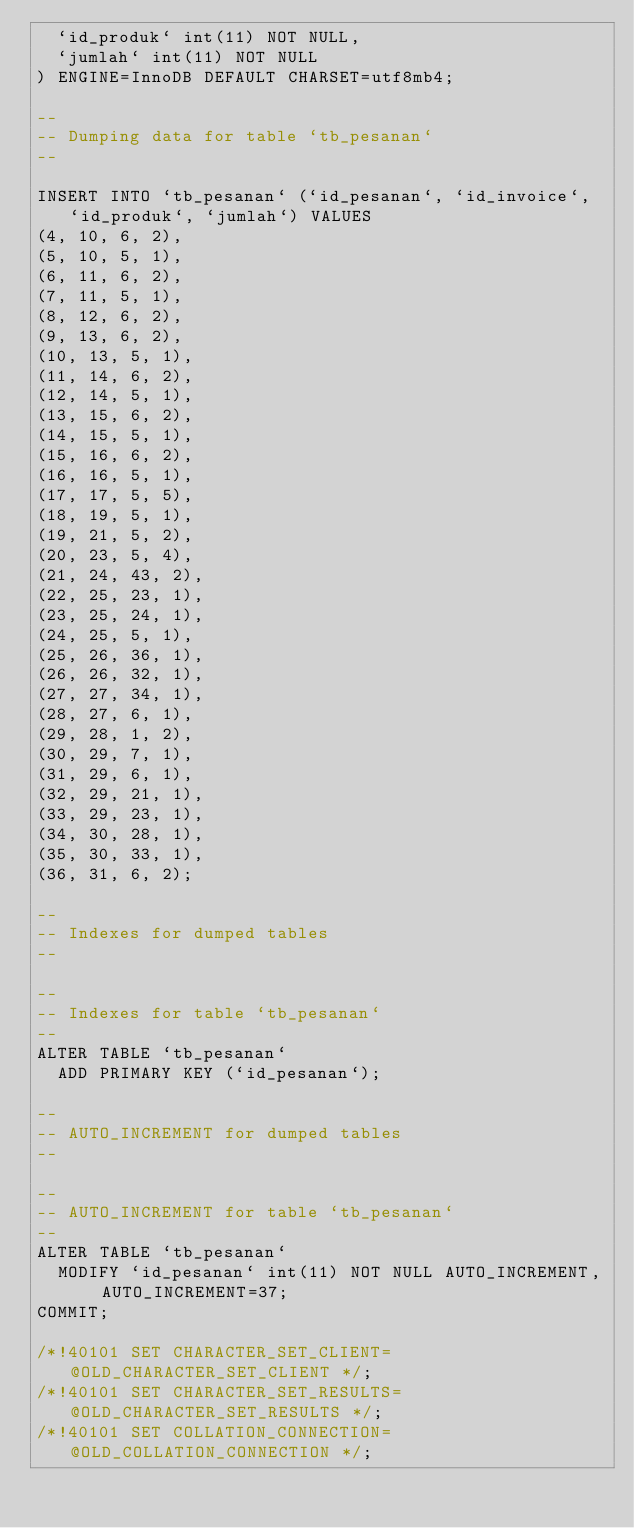Convert code to text. <code><loc_0><loc_0><loc_500><loc_500><_SQL_>  `id_produk` int(11) NOT NULL,
  `jumlah` int(11) NOT NULL
) ENGINE=InnoDB DEFAULT CHARSET=utf8mb4;

--
-- Dumping data for table `tb_pesanan`
--

INSERT INTO `tb_pesanan` (`id_pesanan`, `id_invoice`, `id_produk`, `jumlah`) VALUES
(4, 10, 6, 2),
(5, 10, 5, 1),
(6, 11, 6, 2),
(7, 11, 5, 1),
(8, 12, 6, 2),
(9, 13, 6, 2),
(10, 13, 5, 1),
(11, 14, 6, 2),
(12, 14, 5, 1),
(13, 15, 6, 2),
(14, 15, 5, 1),
(15, 16, 6, 2),
(16, 16, 5, 1),
(17, 17, 5, 5),
(18, 19, 5, 1),
(19, 21, 5, 2),
(20, 23, 5, 4),
(21, 24, 43, 2),
(22, 25, 23, 1),
(23, 25, 24, 1),
(24, 25, 5, 1),
(25, 26, 36, 1),
(26, 26, 32, 1),
(27, 27, 34, 1),
(28, 27, 6, 1),
(29, 28, 1, 2),
(30, 29, 7, 1),
(31, 29, 6, 1),
(32, 29, 21, 1),
(33, 29, 23, 1),
(34, 30, 28, 1),
(35, 30, 33, 1),
(36, 31, 6, 2);

--
-- Indexes for dumped tables
--

--
-- Indexes for table `tb_pesanan`
--
ALTER TABLE `tb_pesanan`
  ADD PRIMARY KEY (`id_pesanan`);

--
-- AUTO_INCREMENT for dumped tables
--

--
-- AUTO_INCREMENT for table `tb_pesanan`
--
ALTER TABLE `tb_pesanan`
  MODIFY `id_pesanan` int(11) NOT NULL AUTO_INCREMENT, AUTO_INCREMENT=37;
COMMIT;

/*!40101 SET CHARACTER_SET_CLIENT=@OLD_CHARACTER_SET_CLIENT */;
/*!40101 SET CHARACTER_SET_RESULTS=@OLD_CHARACTER_SET_RESULTS */;
/*!40101 SET COLLATION_CONNECTION=@OLD_COLLATION_CONNECTION */;
</code> 